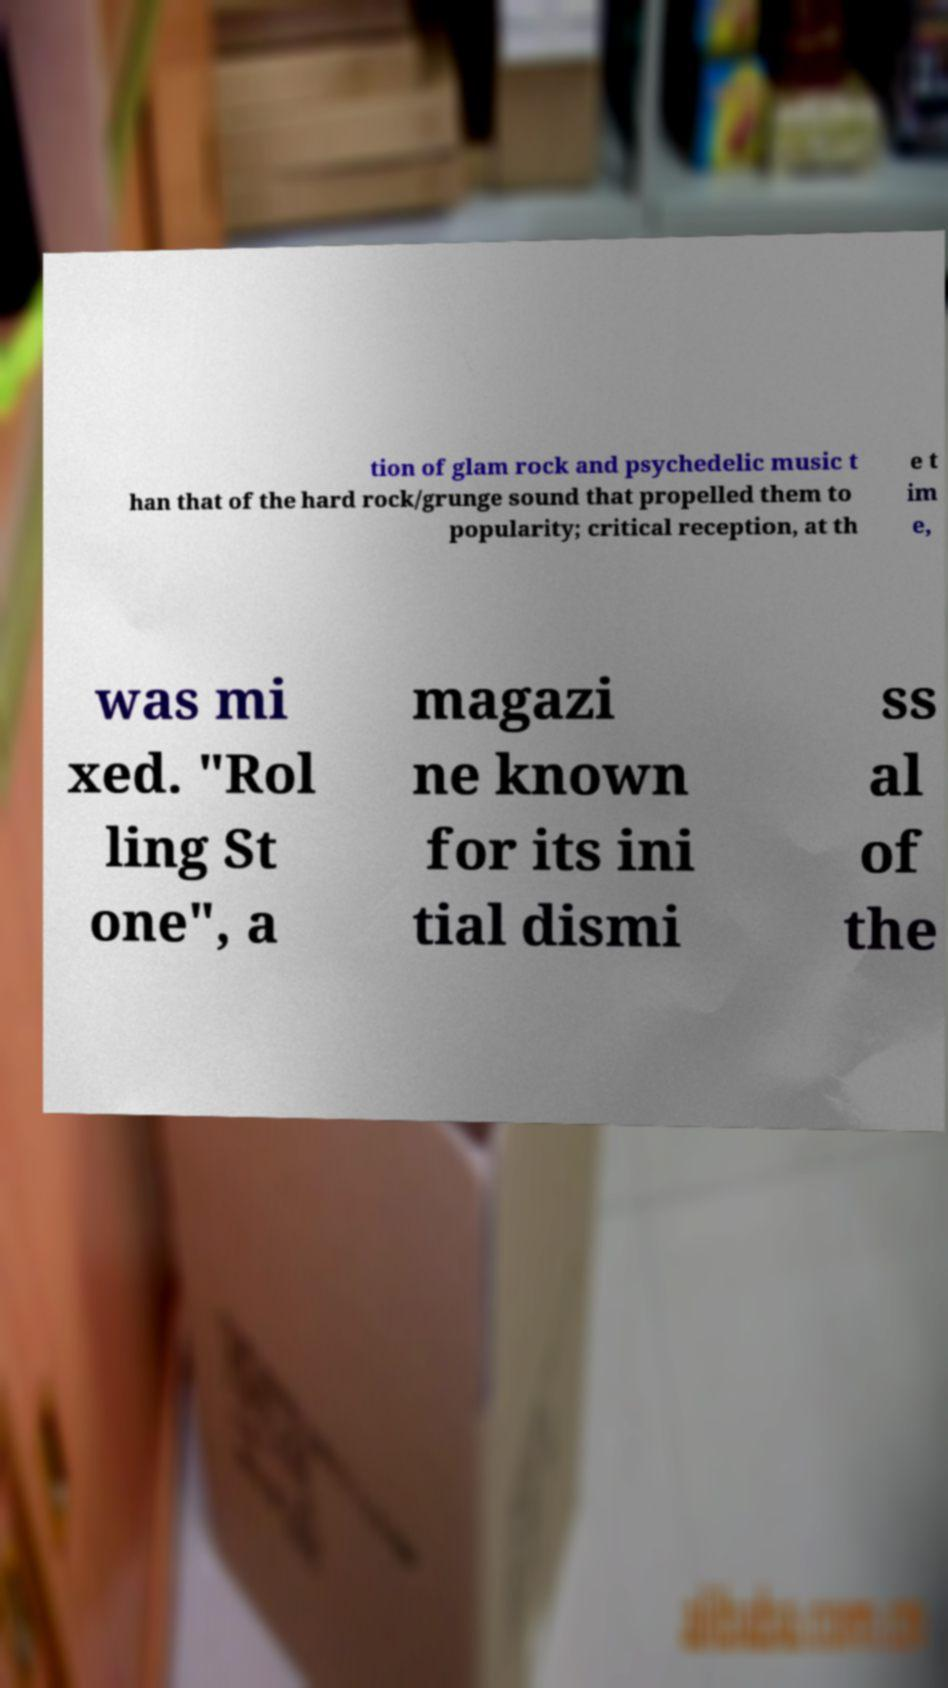What messages or text are displayed in this image? I need them in a readable, typed format. tion of glam rock and psychedelic music t han that of the hard rock/grunge sound that propelled them to popularity; critical reception, at th e t im e, was mi xed. "Rol ling St one", a magazi ne known for its ini tial dismi ss al of the 